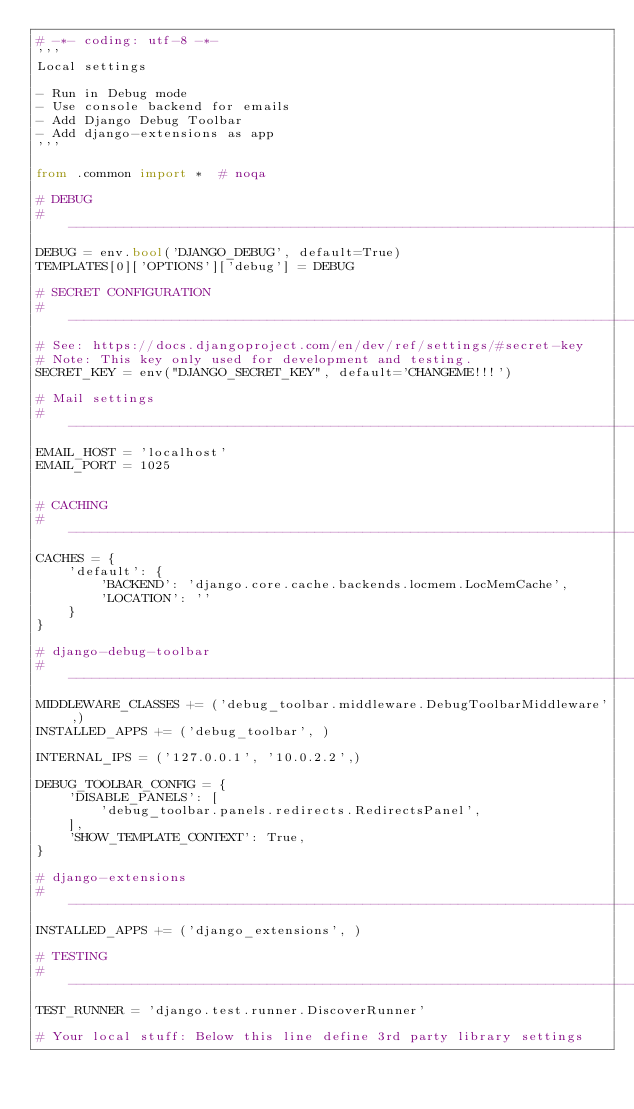Convert code to text. <code><loc_0><loc_0><loc_500><loc_500><_Python_># -*- coding: utf-8 -*-
'''
Local settings

- Run in Debug mode
- Use console backend for emails
- Add Django Debug Toolbar
- Add django-extensions as app
'''

from .common import *  # noqa

# DEBUG
# ------------------------------------------------------------------------------
DEBUG = env.bool('DJANGO_DEBUG', default=True)
TEMPLATES[0]['OPTIONS']['debug'] = DEBUG

# SECRET CONFIGURATION
# ------------------------------------------------------------------------------
# See: https://docs.djangoproject.com/en/dev/ref/settings/#secret-key
# Note: This key only used for development and testing.
SECRET_KEY = env("DJANGO_SECRET_KEY", default='CHANGEME!!!')

# Mail settings
# ------------------------------------------------------------------------------
EMAIL_HOST = 'localhost'
EMAIL_PORT = 1025


# CACHING
# ------------------------------------------------------------------------------
CACHES = {
    'default': {
        'BACKEND': 'django.core.cache.backends.locmem.LocMemCache',
        'LOCATION': ''
    }
}

# django-debug-toolbar
# ------------------------------------------------------------------------------
MIDDLEWARE_CLASSES += ('debug_toolbar.middleware.DebugToolbarMiddleware',)
INSTALLED_APPS += ('debug_toolbar', )

INTERNAL_IPS = ('127.0.0.1', '10.0.2.2',)

DEBUG_TOOLBAR_CONFIG = {
    'DISABLE_PANELS': [
        'debug_toolbar.panels.redirects.RedirectsPanel',
    ],
    'SHOW_TEMPLATE_CONTEXT': True,
}

# django-extensions
# ------------------------------------------------------------------------------
INSTALLED_APPS += ('django_extensions', )

# TESTING
# ------------------------------------------------------------------------------
TEST_RUNNER = 'django.test.runner.DiscoverRunner'

# Your local stuff: Below this line define 3rd party library settings
</code> 